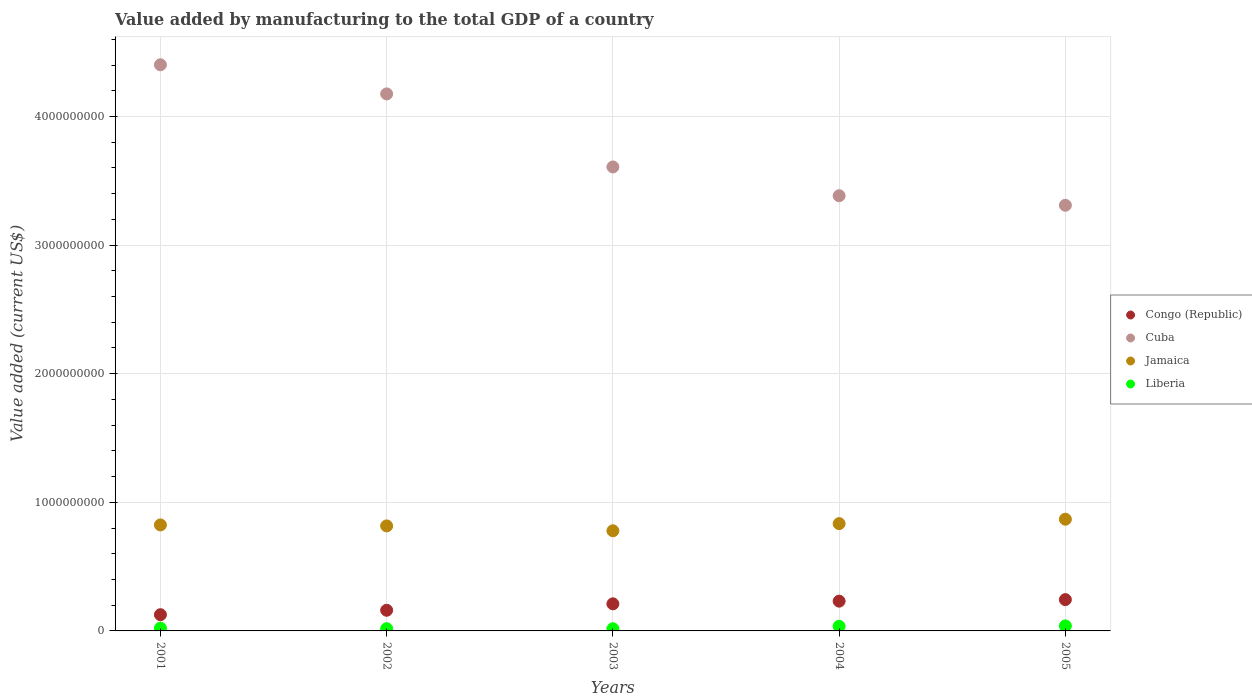Is the number of dotlines equal to the number of legend labels?
Offer a terse response. Yes. What is the value added by manufacturing to the total GDP in Liberia in 2002?
Your answer should be very brief. 1.74e+07. Across all years, what is the maximum value added by manufacturing to the total GDP in Congo (Republic)?
Keep it short and to the point. 2.43e+08. Across all years, what is the minimum value added by manufacturing to the total GDP in Liberia?
Provide a succinct answer. 1.69e+07. In which year was the value added by manufacturing to the total GDP in Jamaica minimum?
Provide a short and direct response. 2003. What is the total value added by manufacturing to the total GDP in Congo (Republic) in the graph?
Offer a terse response. 9.72e+08. What is the difference between the value added by manufacturing to the total GDP in Jamaica in 2001 and that in 2005?
Make the answer very short. -4.44e+07. What is the difference between the value added by manufacturing to the total GDP in Congo (Republic) in 2004 and the value added by manufacturing to the total GDP in Liberia in 2005?
Keep it short and to the point. 1.92e+08. What is the average value added by manufacturing to the total GDP in Liberia per year?
Ensure brevity in your answer.  2.62e+07. In the year 2004, what is the difference between the value added by manufacturing to the total GDP in Jamaica and value added by manufacturing to the total GDP in Cuba?
Offer a very short reply. -2.55e+09. In how many years, is the value added by manufacturing to the total GDP in Jamaica greater than 600000000 US$?
Your answer should be very brief. 5. What is the ratio of the value added by manufacturing to the total GDP in Cuba in 2001 to that in 2005?
Your answer should be very brief. 1.33. Is the value added by manufacturing to the total GDP in Liberia in 2002 less than that in 2004?
Offer a terse response. Yes. What is the difference between the highest and the second highest value added by manufacturing to the total GDP in Congo (Republic)?
Offer a terse response. 1.19e+07. What is the difference between the highest and the lowest value added by manufacturing to the total GDP in Congo (Republic)?
Provide a short and direct response. 1.17e+08. In how many years, is the value added by manufacturing to the total GDP in Liberia greater than the average value added by manufacturing to the total GDP in Liberia taken over all years?
Ensure brevity in your answer.  2. Is it the case that in every year, the sum of the value added by manufacturing to the total GDP in Cuba and value added by manufacturing to the total GDP in Liberia  is greater than the value added by manufacturing to the total GDP in Congo (Republic)?
Ensure brevity in your answer.  Yes. Is the value added by manufacturing to the total GDP in Cuba strictly greater than the value added by manufacturing to the total GDP in Jamaica over the years?
Keep it short and to the point. Yes. Does the graph contain any zero values?
Keep it short and to the point. No. Does the graph contain grids?
Your response must be concise. Yes. How many legend labels are there?
Offer a terse response. 4. How are the legend labels stacked?
Your answer should be very brief. Vertical. What is the title of the graph?
Offer a very short reply. Value added by manufacturing to the total GDP of a country. Does "Greece" appear as one of the legend labels in the graph?
Your response must be concise. No. What is the label or title of the X-axis?
Give a very brief answer. Years. What is the label or title of the Y-axis?
Your answer should be compact. Value added (current US$). What is the Value added (current US$) of Congo (Republic) in 2001?
Offer a terse response. 1.26e+08. What is the Value added (current US$) in Cuba in 2001?
Offer a terse response. 4.40e+09. What is the Value added (current US$) of Jamaica in 2001?
Keep it short and to the point. 8.24e+08. What is the Value added (current US$) of Liberia in 2001?
Keep it short and to the point. 2.15e+07. What is the Value added (current US$) in Congo (Republic) in 2002?
Keep it short and to the point. 1.61e+08. What is the Value added (current US$) of Cuba in 2002?
Make the answer very short. 4.18e+09. What is the Value added (current US$) of Jamaica in 2002?
Give a very brief answer. 8.16e+08. What is the Value added (current US$) in Liberia in 2002?
Offer a very short reply. 1.74e+07. What is the Value added (current US$) in Congo (Republic) in 2003?
Your answer should be compact. 2.11e+08. What is the Value added (current US$) of Cuba in 2003?
Your response must be concise. 3.61e+09. What is the Value added (current US$) of Jamaica in 2003?
Offer a very short reply. 7.79e+08. What is the Value added (current US$) of Liberia in 2003?
Offer a very short reply. 1.69e+07. What is the Value added (current US$) of Congo (Republic) in 2004?
Your response must be concise. 2.32e+08. What is the Value added (current US$) in Cuba in 2004?
Make the answer very short. 3.38e+09. What is the Value added (current US$) of Jamaica in 2004?
Give a very brief answer. 8.34e+08. What is the Value added (current US$) in Liberia in 2004?
Give a very brief answer. 3.61e+07. What is the Value added (current US$) in Congo (Republic) in 2005?
Provide a short and direct response. 2.43e+08. What is the Value added (current US$) in Cuba in 2005?
Ensure brevity in your answer.  3.31e+09. What is the Value added (current US$) in Jamaica in 2005?
Provide a succinct answer. 8.69e+08. What is the Value added (current US$) in Liberia in 2005?
Your answer should be very brief. 3.92e+07. Across all years, what is the maximum Value added (current US$) in Congo (Republic)?
Provide a succinct answer. 2.43e+08. Across all years, what is the maximum Value added (current US$) of Cuba?
Make the answer very short. 4.40e+09. Across all years, what is the maximum Value added (current US$) in Jamaica?
Make the answer very short. 8.69e+08. Across all years, what is the maximum Value added (current US$) in Liberia?
Your response must be concise. 3.92e+07. Across all years, what is the minimum Value added (current US$) of Congo (Republic)?
Provide a short and direct response. 1.26e+08. Across all years, what is the minimum Value added (current US$) in Cuba?
Offer a very short reply. 3.31e+09. Across all years, what is the minimum Value added (current US$) of Jamaica?
Your answer should be very brief. 7.79e+08. Across all years, what is the minimum Value added (current US$) of Liberia?
Provide a short and direct response. 1.69e+07. What is the total Value added (current US$) in Congo (Republic) in the graph?
Provide a succinct answer. 9.72e+08. What is the total Value added (current US$) in Cuba in the graph?
Keep it short and to the point. 1.89e+1. What is the total Value added (current US$) in Jamaica in the graph?
Make the answer very short. 4.12e+09. What is the total Value added (current US$) of Liberia in the graph?
Provide a short and direct response. 1.31e+08. What is the difference between the Value added (current US$) of Congo (Republic) in 2001 and that in 2002?
Offer a terse response. -3.46e+07. What is the difference between the Value added (current US$) of Cuba in 2001 and that in 2002?
Provide a succinct answer. 2.26e+08. What is the difference between the Value added (current US$) in Jamaica in 2001 and that in 2002?
Ensure brevity in your answer.  7.68e+06. What is the difference between the Value added (current US$) in Liberia in 2001 and that in 2002?
Make the answer very short. 4.16e+06. What is the difference between the Value added (current US$) of Congo (Republic) in 2001 and that in 2003?
Offer a very short reply. -8.45e+07. What is the difference between the Value added (current US$) of Cuba in 2001 and that in 2003?
Keep it short and to the point. 7.94e+08. What is the difference between the Value added (current US$) in Jamaica in 2001 and that in 2003?
Provide a succinct answer. 4.55e+07. What is the difference between the Value added (current US$) of Liberia in 2001 and that in 2003?
Offer a very short reply. 4.65e+06. What is the difference between the Value added (current US$) of Congo (Republic) in 2001 and that in 2004?
Your answer should be very brief. -1.05e+08. What is the difference between the Value added (current US$) in Cuba in 2001 and that in 2004?
Your response must be concise. 1.02e+09. What is the difference between the Value added (current US$) in Jamaica in 2001 and that in 2004?
Provide a succinct answer. -1.01e+07. What is the difference between the Value added (current US$) in Liberia in 2001 and that in 2004?
Keep it short and to the point. -1.46e+07. What is the difference between the Value added (current US$) of Congo (Republic) in 2001 and that in 2005?
Keep it short and to the point. -1.17e+08. What is the difference between the Value added (current US$) in Cuba in 2001 and that in 2005?
Your answer should be very brief. 1.09e+09. What is the difference between the Value added (current US$) in Jamaica in 2001 and that in 2005?
Keep it short and to the point. -4.44e+07. What is the difference between the Value added (current US$) of Liberia in 2001 and that in 2005?
Your response must be concise. -1.76e+07. What is the difference between the Value added (current US$) in Congo (Republic) in 2002 and that in 2003?
Your answer should be compact. -4.99e+07. What is the difference between the Value added (current US$) of Cuba in 2002 and that in 2003?
Ensure brevity in your answer.  5.68e+08. What is the difference between the Value added (current US$) in Jamaica in 2002 and that in 2003?
Ensure brevity in your answer.  3.78e+07. What is the difference between the Value added (current US$) in Liberia in 2002 and that in 2003?
Provide a short and direct response. 4.92e+05. What is the difference between the Value added (current US$) of Congo (Republic) in 2002 and that in 2004?
Provide a short and direct response. -7.08e+07. What is the difference between the Value added (current US$) in Cuba in 2002 and that in 2004?
Provide a short and direct response. 7.92e+08. What is the difference between the Value added (current US$) of Jamaica in 2002 and that in 2004?
Keep it short and to the point. -1.77e+07. What is the difference between the Value added (current US$) of Liberia in 2002 and that in 2004?
Your answer should be compact. -1.87e+07. What is the difference between the Value added (current US$) in Congo (Republic) in 2002 and that in 2005?
Your answer should be very brief. -8.27e+07. What is the difference between the Value added (current US$) in Cuba in 2002 and that in 2005?
Offer a terse response. 8.66e+08. What is the difference between the Value added (current US$) in Jamaica in 2002 and that in 2005?
Provide a succinct answer. -5.21e+07. What is the difference between the Value added (current US$) of Liberia in 2002 and that in 2005?
Offer a terse response. -2.18e+07. What is the difference between the Value added (current US$) in Congo (Republic) in 2003 and that in 2004?
Ensure brevity in your answer.  -2.09e+07. What is the difference between the Value added (current US$) of Cuba in 2003 and that in 2004?
Your answer should be compact. 2.24e+08. What is the difference between the Value added (current US$) in Jamaica in 2003 and that in 2004?
Your answer should be very brief. -5.55e+07. What is the difference between the Value added (current US$) in Liberia in 2003 and that in 2004?
Ensure brevity in your answer.  -1.92e+07. What is the difference between the Value added (current US$) of Congo (Republic) in 2003 and that in 2005?
Give a very brief answer. -3.28e+07. What is the difference between the Value added (current US$) in Cuba in 2003 and that in 2005?
Ensure brevity in your answer.  2.98e+08. What is the difference between the Value added (current US$) of Jamaica in 2003 and that in 2005?
Offer a very short reply. -8.99e+07. What is the difference between the Value added (current US$) of Liberia in 2003 and that in 2005?
Provide a succinct answer. -2.23e+07. What is the difference between the Value added (current US$) in Congo (Republic) in 2004 and that in 2005?
Offer a terse response. -1.19e+07. What is the difference between the Value added (current US$) in Cuba in 2004 and that in 2005?
Your answer should be very brief. 7.40e+07. What is the difference between the Value added (current US$) of Jamaica in 2004 and that in 2005?
Your answer should be very brief. -3.44e+07. What is the difference between the Value added (current US$) in Liberia in 2004 and that in 2005?
Your answer should be very brief. -3.07e+06. What is the difference between the Value added (current US$) in Congo (Republic) in 2001 and the Value added (current US$) in Cuba in 2002?
Provide a short and direct response. -4.05e+09. What is the difference between the Value added (current US$) of Congo (Republic) in 2001 and the Value added (current US$) of Jamaica in 2002?
Provide a short and direct response. -6.90e+08. What is the difference between the Value added (current US$) of Congo (Republic) in 2001 and the Value added (current US$) of Liberia in 2002?
Keep it short and to the point. 1.09e+08. What is the difference between the Value added (current US$) of Cuba in 2001 and the Value added (current US$) of Jamaica in 2002?
Ensure brevity in your answer.  3.59e+09. What is the difference between the Value added (current US$) in Cuba in 2001 and the Value added (current US$) in Liberia in 2002?
Your answer should be compact. 4.38e+09. What is the difference between the Value added (current US$) of Jamaica in 2001 and the Value added (current US$) of Liberia in 2002?
Ensure brevity in your answer.  8.07e+08. What is the difference between the Value added (current US$) of Congo (Republic) in 2001 and the Value added (current US$) of Cuba in 2003?
Your response must be concise. -3.48e+09. What is the difference between the Value added (current US$) of Congo (Republic) in 2001 and the Value added (current US$) of Jamaica in 2003?
Your answer should be compact. -6.53e+08. What is the difference between the Value added (current US$) in Congo (Republic) in 2001 and the Value added (current US$) in Liberia in 2003?
Provide a short and direct response. 1.09e+08. What is the difference between the Value added (current US$) of Cuba in 2001 and the Value added (current US$) of Jamaica in 2003?
Make the answer very short. 3.62e+09. What is the difference between the Value added (current US$) of Cuba in 2001 and the Value added (current US$) of Liberia in 2003?
Make the answer very short. 4.38e+09. What is the difference between the Value added (current US$) of Jamaica in 2001 and the Value added (current US$) of Liberia in 2003?
Your response must be concise. 8.07e+08. What is the difference between the Value added (current US$) of Congo (Republic) in 2001 and the Value added (current US$) of Cuba in 2004?
Make the answer very short. -3.26e+09. What is the difference between the Value added (current US$) in Congo (Republic) in 2001 and the Value added (current US$) in Jamaica in 2004?
Offer a very short reply. -7.08e+08. What is the difference between the Value added (current US$) in Congo (Republic) in 2001 and the Value added (current US$) in Liberia in 2004?
Make the answer very short. 8.99e+07. What is the difference between the Value added (current US$) in Cuba in 2001 and the Value added (current US$) in Jamaica in 2004?
Your answer should be compact. 3.57e+09. What is the difference between the Value added (current US$) in Cuba in 2001 and the Value added (current US$) in Liberia in 2004?
Your answer should be very brief. 4.37e+09. What is the difference between the Value added (current US$) of Jamaica in 2001 and the Value added (current US$) of Liberia in 2004?
Provide a succinct answer. 7.88e+08. What is the difference between the Value added (current US$) of Congo (Republic) in 2001 and the Value added (current US$) of Cuba in 2005?
Ensure brevity in your answer.  -3.18e+09. What is the difference between the Value added (current US$) of Congo (Republic) in 2001 and the Value added (current US$) of Jamaica in 2005?
Provide a short and direct response. -7.42e+08. What is the difference between the Value added (current US$) in Congo (Republic) in 2001 and the Value added (current US$) in Liberia in 2005?
Your answer should be very brief. 8.69e+07. What is the difference between the Value added (current US$) in Cuba in 2001 and the Value added (current US$) in Jamaica in 2005?
Offer a very short reply. 3.53e+09. What is the difference between the Value added (current US$) of Cuba in 2001 and the Value added (current US$) of Liberia in 2005?
Your answer should be very brief. 4.36e+09. What is the difference between the Value added (current US$) in Jamaica in 2001 and the Value added (current US$) in Liberia in 2005?
Your response must be concise. 7.85e+08. What is the difference between the Value added (current US$) of Congo (Republic) in 2002 and the Value added (current US$) of Cuba in 2003?
Your response must be concise. -3.45e+09. What is the difference between the Value added (current US$) in Congo (Republic) in 2002 and the Value added (current US$) in Jamaica in 2003?
Provide a succinct answer. -6.18e+08. What is the difference between the Value added (current US$) of Congo (Republic) in 2002 and the Value added (current US$) of Liberia in 2003?
Your answer should be compact. 1.44e+08. What is the difference between the Value added (current US$) in Cuba in 2002 and the Value added (current US$) in Jamaica in 2003?
Offer a very short reply. 3.40e+09. What is the difference between the Value added (current US$) in Cuba in 2002 and the Value added (current US$) in Liberia in 2003?
Your answer should be very brief. 4.16e+09. What is the difference between the Value added (current US$) in Jamaica in 2002 and the Value added (current US$) in Liberia in 2003?
Your answer should be compact. 8.00e+08. What is the difference between the Value added (current US$) in Congo (Republic) in 2002 and the Value added (current US$) in Cuba in 2004?
Ensure brevity in your answer.  -3.22e+09. What is the difference between the Value added (current US$) in Congo (Republic) in 2002 and the Value added (current US$) in Jamaica in 2004?
Provide a short and direct response. -6.73e+08. What is the difference between the Value added (current US$) of Congo (Republic) in 2002 and the Value added (current US$) of Liberia in 2004?
Make the answer very short. 1.25e+08. What is the difference between the Value added (current US$) in Cuba in 2002 and the Value added (current US$) in Jamaica in 2004?
Make the answer very short. 3.34e+09. What is the difference between the Value added (current US$) in Cuba in 2002 and the Value added (current US$) in Liberia in 2004?
Your answer should be very brief. 4.14e+09. What is the difference between the Value added (current US$) in Jamaica in 2002 and the Value added (current US$) in Liberia in 2004?
Ensure brevity in your answer.  7.80e+08. What is the difference between the Value added (current US$) in Congo (Republic) in 2002 and the Value added (current US$) in Cuba in 2005?
Your answer should be compact. -3.15e+09. What is the difference between the Value added (current US$) of Congo (Republic) in 2002 and the Value added (current US$) of Jamaica in 2005?
Keep it short and to the point. -7.08e+08. What is the difference between the Value added (current US$) in Congo (Republic) in 2002 and the Value added (current US$) in Liberia in 2005?
Keep it short and to the point. 1.22e+08. What is the difference between the Value added (current US$) in Cuba in 2002 and the Value added (current US$) in Jamaica in 2005?
Make the answer very short. 3.31e+09. What is the difference between the Value added (current US$) in Cuba in 2002 and the Value added (current US$) in Liberia in 2005?
Your answer should be very brief. 4.14e+09. What is the difference between the Value added (current US$) of Jamaica in 2002 and the Value added (current US$) of Liberia in 2005?
Give a very brief answer. 7.77e+08. What is the difference between the Value added (current US$) in Congo (Republic) in 2003 and the Value added (current US$) in Cuba in 2004?
Provide a short and direct response. -3.17e+09. What is the difference between the Value added (current US$) of Congo (Republic) in 2003 and the Value added (current US$) of Jamaica in 2004?
Offer a very short reply. -6.24e+08. What is the difference between the Value added (current US$) of Congo (Republic) in 2003 and the Value added (current US$) of Liberia in 2004?
Your answer should be very brief. 1.74e+08. What is the difference between the Value added (current US$) in Cuba in 2003 and the Value added (current US$) in Jamaica in 2004?
Offer a very short reply. 2.77e+09. What is the difference between the Value added (current US$) of Cuba in 2003 and the Value added (current US$) of Liberia in 2004?
Your answer should be compact. 3.57e+09. What is the difference between the Value added (current US$) of Jamaica in 2003 and the Value added (current US$) of Liberia in 2004?
Keep it short and to the point. 7.43e+08. What is the difference between the Value added (current US$) in Congo (Republic) in 2003 and the Value added (current US$) in Cuba in 2005?
Make the answer very short. -3.10e+09. What is the difference between the Value added (current US$) of Congo (Republic) in 2003 and the Value added (current US$) of Jamaica in 2005?
Keep it short and to the point. -6.58e+08. What is the difference between the Value added (current US$) in Congo (Republic) in 2003 and the Value added (current US$) in Liberia in 2005?
Ensure brevity in your answer.  1.71e+08. What is the difference between the Value added (current US$) in Cuba in 2003 and the Value added (current US$) in Jamaica in 2005?
Ensure brevity in your answer.  2.74e+09. What is the difference between the Value added (current US$) in Cuba in 2003 and the Value added (current US$) in Liberia in 2005?
Offer a terse response. 3.57e+09. What is the difference between the Value added (current US$) in Jamaica in 2003 and the Value added (current US$) in Liberia in 2005?
Provide a succinct answer. 7.39e+08. What is the difference between the Value added (current US$) of Congo (Republic) in 2004 and the Value added (current US$) of Cuba in 2005?
Make the answer very short. -3.08e+09. What is the difference between the Value added (current US$) in Congo (Republic) in 2004 and the Value added (current US$) in Jamaica in 2005?
Give a very brief answer. -6.37e+08. What is the difference between the Value added (current US$) of Congo (Republic) in 2004 and the Value added (current US$) of Liberia in 2005?
Keep it short and to the point. 1.92e+08. What is the difference between the Value added (current US$) of Cuba in 2004 and the Value added (current US$) of Jamaica in 2005?
Give a very brief answer. 2.51e+09. What is the difference between the Value added (current US$) of Cuba in 2004 and the Value added (current US$) of Liberia in 2005?
Offer a very short reply. 3.34e+09. What is the difference between the Value added (current US$) in Jamaica in 2004 and the Value added (current US$) in Liberia in 2005?
Your answer should be very brief. 7.95e+08. What is the average Value added (current US$) of Congo (Republic) per year?
Provide a succinct answer. 1.94e+08. What is the average Value added (current US$) of Cuba per year?
Make the answer very short. 3.78e+09. What is the average Value added (current US$) in Jamaica per year?
Provide a short and direct response. 8.24e+08. What is the average Value added (current US$) of Liberia per year?
Your answer should be very brief. 2.62e+07. In the year 2001, what is the difference between the Value added (current US$) of Congo (Republic) and Value added (current US$) of Cuba?
Your answer should be compact. -4.28e+09. In the year 2001, what is the difference between the Value added (current US$) in Congo (Republic) and Value added (current US$) in Jamaica?
Make the answer very short. -6.98e+08. In the year 2001, what is the difference between the Value added (current US$) of Congo (Republic) and Value added (current US$) of Liberia?
Offer a very short reply. 1.05e+08. In the year 2001, what is the difference between the Value added (current US$) of Cuba and Value added (current US$) of Jamaica?
Offer a terse response. 3.58e+09. In the year 2001, what is the difference between the Value added (current US$) of Cuba and Value added (current US$) of Liberia?
Provide a short and direct response. 4.38e+09. In the year 2001, what is the difference between the Value added (current US$) of Jamaica and Value added (current US$) of Liberia?
Ensure brevity in your answer.  8.03e+08. In the year 2002, what is the difference between the Value added (current US$) in Congo (Republic) and Value added (current US$) in Cuba?
Keep it short and to the point. -4.01e+09. In the year 2002, what is the difference between the Value added (current US$) of Congo (Republic) and Value added (current US$) of Jamaica?
Give a very brief answer. -6.56e+08. In the year 2002, what is the difference between the Value added (current US$) in Congo (Republic) and Value added (current US$) in Liberia?
Ensure brevity in your answer.  1.43e+08. In the year 2002, what is the difference between the Value added (current US$) of Cuba and Value added (current US$) of Jamaica?
Your answer should be compact. 3.36e+09. In the year 2002, what is the difference between the Value added (current US$) in Cuba and Value added (current US$) in Liberia?
Provide a succinct answer. 4.16e+09. In the year 2002, what is the difference between the Value added (current US$) of Jamaica and Value added (current US$) of Liberia?
Give a very brief answer. 7.99e+08. In the year 2003, what is the difference between the Value added (current US$) of Congo (Republic) and Value added (current US$) of Cuba?
Give a very brief answer. -3.40e+09. In the year 2003, what is the difference between the Value added (current US$) in Congo (Republic) and Value added (current US$) in Jamaica?
Provide a short and direct response. -5.68e+08. In the year 2003, what is the difference between the Value added (current US$) in Congo (Republic) and Value added (current US$) in Liberia?
Your answer should be very brief. 1.94e+08. In the year 2003, what is the difference between the Value added (current US$) of Cuba and Value added (current US$) of Jamaica?
Your answer should be very brief. 2.83e+09. In the year 2003, what is the difference between the Value added (current US$) in Cuba and Value added (current US$) in Liberia?
Give a very brief answer. 3.59e+09. In the year 2003, what is the difference between the Value added (current US$) of Jamaica and Value added (current US$) of Liberia?
Make the answer very short. 7.62e+08. In the year 2004, what is the difference between the Value added (current US$) of Congo (Republic) and Value added (current US$) of Cuba?
Keep it short and to the point. -3.15e+09. In the year 2004, what is the difference between the Value added (current US$) in Congo (Republic) and Value added (current US$) in Jamaica?
Give a very brief answer. -6.03e+08. In the year 2004, what is the difference between the Value added (current US$) of Congo (Republic) and Value added (current US$) of Liberia?
Your response must be concise. 1.95e+08. In the year 2004, what is the difference between the Value added (current US$) of Cuba and Value added (current US$) of Jamaica?
Provide a succinct answer. 2.55e+09. In the year 2004, what is the difference between the Value added (current US$) in Cuba and Value added (current US$) in Liberia?
Offer a terse response. 3.35e+09. In the year 2004, what is the difference between the Value added (current US$) in Jamaica and Value added (current US$) in Liberia?
Your answer should be very brief. 7.98e+08. In the year 2005, what is the difference between the Value added (current US$) of Congo (Republic) and Value added (current US$) of Cuba?
Offer a terse response. -3.07e+09. In the year 2005, what is the difference between the Value added (current US$) of Congo (Republic) and Value added (current US$) of Jamaica?
Keep it short and to the point. -6.25e+08. In the year 2005, what is the difference between the Value added (current US$) in Congo (Republic) and Value added (current US$) in Liberia?
Give a very brief answer. 2.04e+08. In the year 2005, what is the difference between the Value added (current US$) in Cuba and Value added (current US$) in Jamaica?
Offer a terse response. 2.44e+09. In the year 2005, what is the difference between the Value added (current US$) of Cuba and Value added (current US$) of Liberia?
Make the answer very short. 3.27e+09. In the year 2005, what is the difference between the Value added (current US$) in Jamaica and Value added (current US$) in Liberia?
Provide a short and direct response. 8.29e+08. What is the ratio of the Value added (current US$) in Congo (Republic) in 2001 to that in 2002?
Offer a very short reply. 0.78. What is the ratio of the Value added (current US$) in Cuba in 2001 to that in 2002?
Provide a short and direct response. 1.05. What is the ratio of the Value added (current US$) in Jamaica in 2001 to that in 2002?
Offer a very short reply. 1.01. What is the ratio of the Value added (current US$) of Liberia in 2001 to that in 2002?
Offer a terse response. 1.24. What is the ratio of the Value added (current US$) of Congo (Republic) in 2001 to that in 2003?
Provide a succinct answer. 0.6. What is the ratio of the Value added (current US$) of Cuba in 2001 to that in 2003?
Your response must be concise. 1.22. What is the ratio of the Value added (current US$) in Jamaica in 2001 to that in 2003?
Your answer should be compact. 1.06. What is the ratio of the Value added (current US$) of Liberia in 2001 to that in 2003?
Offer a very short reply. 1.28. What is the ratio of the Value added (current US$) of Congo (Republic) in 2001 to that in 2004?
Your answer should be very brief. 0.54. What is the ratio of the Value added (current US$) in Cuba in 2001 to that in 2004?
Make the answer very short. 1.3. What is the ratio of the Value added (current US$) of Jamaica in 2001 to that in 2004?
Keep it short and to the point. 0.99. What is the ratio of the Value added (current US$) of Liberia in 2001 to that in 2004?
Your response must be concise. 0.6. What is the ratio of the Value added (current US$) in Congo (Republic) in 2001 to that in 2005?
Keep it short and to the point. 0.52. What is the ratio of the Value added (current US$) of Cuba in 2001 to that in 2005?
Provide a short and direct response. 1.33. What is the ratio of the Value added (current US$) in Jamaica in 2001 to that in 2005?
Your answer should be compact. 0.95. What is the ratio of the Value added (current US$) of Liberia in 2001 to that in 2005?
Your response must be concise. 0.55. What is the ratio of the Value added (current US$) of Congo (Republic) in 2002 to that in 2003?
Make the answer very short. 0.76. What is the ratio of the Value added (current US$) in Cuba in 2002 to that in 2003?
Make the answer very short. 1.16. What is the ratio of the Value added (current US$) in Jamaica in 2002 to that in 2003?
Offer a terse response. 1.05. What is the ratio of the Value added (current US$) of Liberia in 2002 to that in 2003?
Your answer should be compact. 1.03. What is the ratio of the Value added (current US$) in Congo (Republic) in 2002 to that in 2004?
Your response must be concise. 0.69. What is the ratio of the Value added (current US$) in Cuba in 2002 to that in 2004?
Your response must be concise. 1.23. What is the ratio of the Value added (current US$) of Jamaica in 2002 to that in 2004?
Offer a very short reply. 0.98. What is the ratio of the Value added (current US$) in Liberia in 2002 to that in 2004?
Keep it short and to the point. 0.48. What is the ratio of the Value added (current US$) in Congo (Republic) in 2002 to that in 2005?
Your answer should be compact. 0.66. What is the ratio of the Value added (current US$) of Cuba in 2002 to that in 2005?
Give a very brief answer. 1.26. What is the ratio of the Value added (current US$) of Liberia in 2002 to that in 2005?
Provide a short and direct response. 0.44. What is the ratio of the Value added (current US$) of Congo (Republic) in 2003 to that in 2004?
Provide a succinct answer. 0.91. What is the ratio of the Value added (current US$) in Cuba in 2003 to that in 2004?
Your response must be concise. 1.07. What is the ratio of the Value added (current US$) of Jamaica in 2003 to that in 2004?
Give a very brief answer. 0.93. What is the ratio of the Value added (current US$) of Liberia in 2003 to that in 2004?
Keep it short and to the point. 0.47. What is the ratio of the Value added (current US$) in Congo (Republic) in 2003 to that in 2005?
Provide a short and direct response. 0.87. What is the ratio of the Value added (current US$) of Cuba in 2003 to that in 2005?
Offer a terse response. 1.09. What is the ratio of the Value added (current US$) in Jamaica in 2003 to that in 2005?
Make the answer very short. 0.9. What is the ratio of the Value added (current US$) of Liberia in 2003 to that in 2005?
Your answer should be compact. 0.43. What is the ratio of the Value added (current US$) of Congo (Republic) in 2004 to that in 2005?
Offer a terse response. 0.95. What is the ratio of the Value added (current US$) in Cuba in 2004 to that in 2005?
Your response must be concise. 1.02. What is the ratio of the Value added (current US$) in Jamaica in 2004 to that in 2005?
Give a very brief answer. 0.96. What is the ratio of the Value added (current US$) of Liberia in 2004 to that in 2005?
Provide a succinct answer. 0.92. What is the difference between the highest and the second highest Value added (current US$) in Congo (Republic)?
Your answer should be compact. 1.19e+07. What is the difference between the highest and the second highest Value added (current US$) in Cuba?
Your answer should be compact. 2.26e+08. What is the difference between the highest and the second highest Value added (current US$) of Jamaica?
Make the answer very short. 3.44e+07. What is the difference between the highest and the second highest Value added (current US$) of Liberia?
Your response must be concise. 3.07e+06. What is the difference between the highest and the lowest Value added (current US$) of Congo (Republic)?
Make the answer very short. 1.17e+08. What is the difference between the highest and the lowest Value added (current US$) of Cuba?
Provide a short and direct response. 1.09e+09. What is the difference between the highest and the lowest Value added (current US$) of Jamaica?
Your response must be concise. 8.99e+07. What is the difference between the highest and the lowest Value added (current US$) in Liberia?
Your response must be concise. 2.23e+07. 